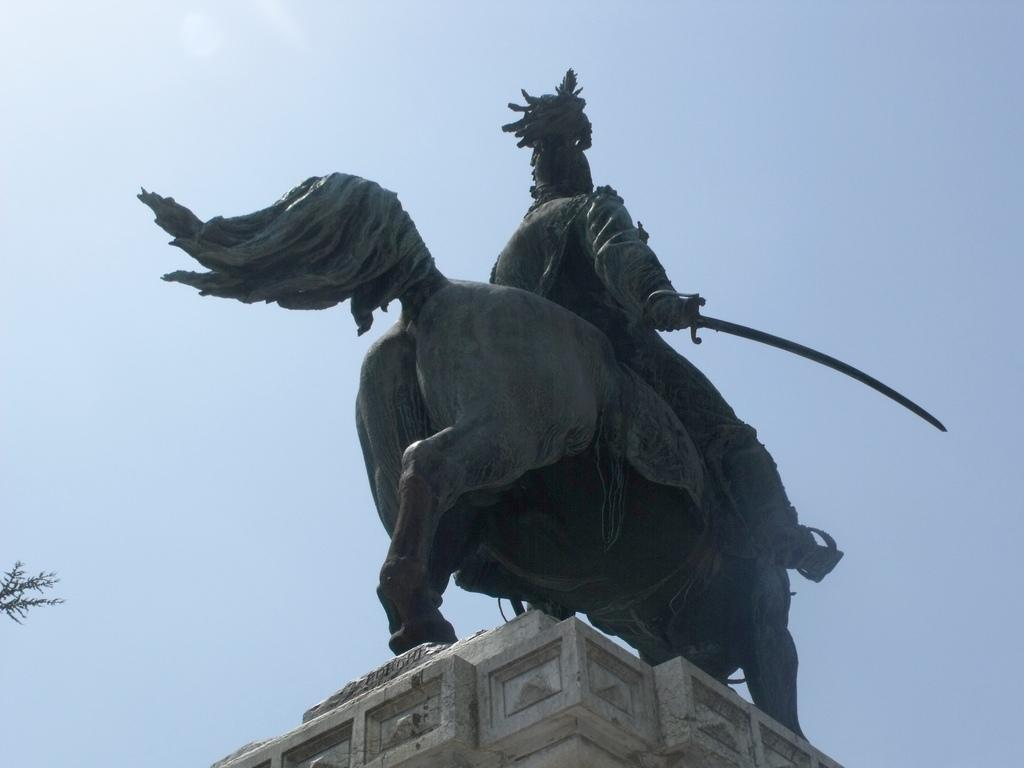What subjects are depicted in the sculptures on the platform? There are sculptures of a person and an animal on a platform. What can be seen in the background of the image? The background of the image includes the sky. What type of vegetation is visible on the left side of the image? Leaves are visible on the left side of the image. Where is the donkey located in the image? There is no donkey present in the image; the sculpture depicts an animal, but it is not specified as a donkey. 